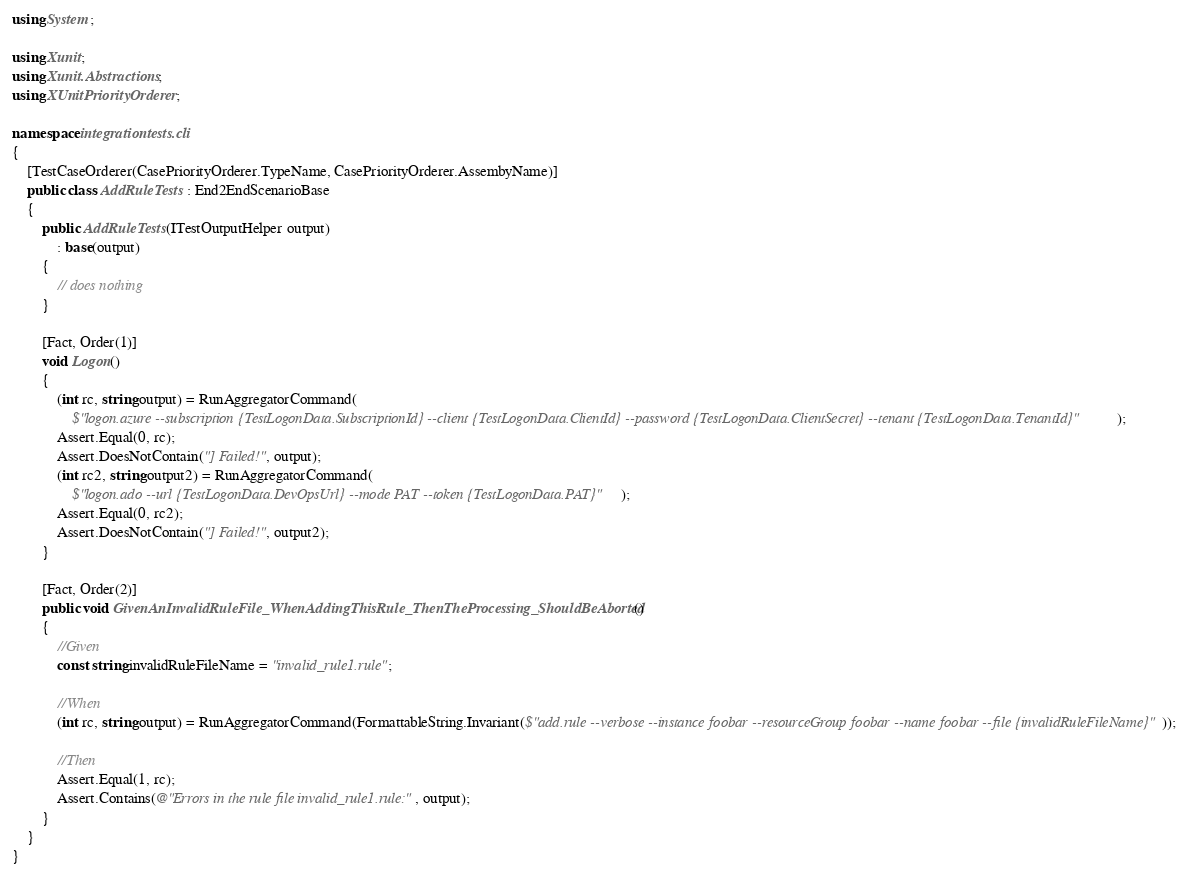<code> <loc_0><loc_0><loc_500><loc_500><_C#_>using System;

using Xunit;
using Xunit.Abstractions;
using XUnitPriorityOrderer;

namespace integrationtests.cli
{
    [TestCaseOrderer(CasePriorityOrderer.TypeName, CasePriorityOrderer.AssembyName)]
    public class AddRuleTests : End2EndScenarioBase
    {
        public AddRuleTests(ITestOutputHelper output)
            : base(output)
        {
            // does nothing
        }

        [Fact, Order(1)]
        void Logon()
        {
            (int rc, string output) = RunAggregatorCommand(
                $"logon.azure --subscription {TestLogonData.SubscriptionId} --client {TestLogonData.ClientId} --password {TestLogonData.ClientSecret} --tenant {TestLogonData.TenantId}");
            Assert.Equal(0, rc);
            Assert.DoesNotContain("] Failed!", output);
            (int rc2, string output2) = RunAggregatorCommand(
                $"logon.ado --url {TestLogonData.DevOpsUrl} --mode PAT --token {TestLogonData.PAT}");
            Assert.Equal(0, rc2);
            Assert.DoesNotContain("] Failed!", output2);
        }

        [Fact, Order(2)]
        public void GivenAnInvalidRuleFile_WhenAddingThisRule_ThenTheProcessing_ShouldBeAborted()
        {
            //Given
            const string invalidRuleFileName = "invalid_rule1.rule";

            //When
            (int rc, string output) = RunAggregatorCommand(FormattableString.Invariant($"add.rule --verbose --instance foobar --resourceGroup foobar --name foobar --file {invalidRuleFileName}"));

            //Then
            Assert.Equal(1, rc);
            Assert.Contains(@"Errors in the rule file invalid_rule1.rule:", output);
        }
    }
}</code> 